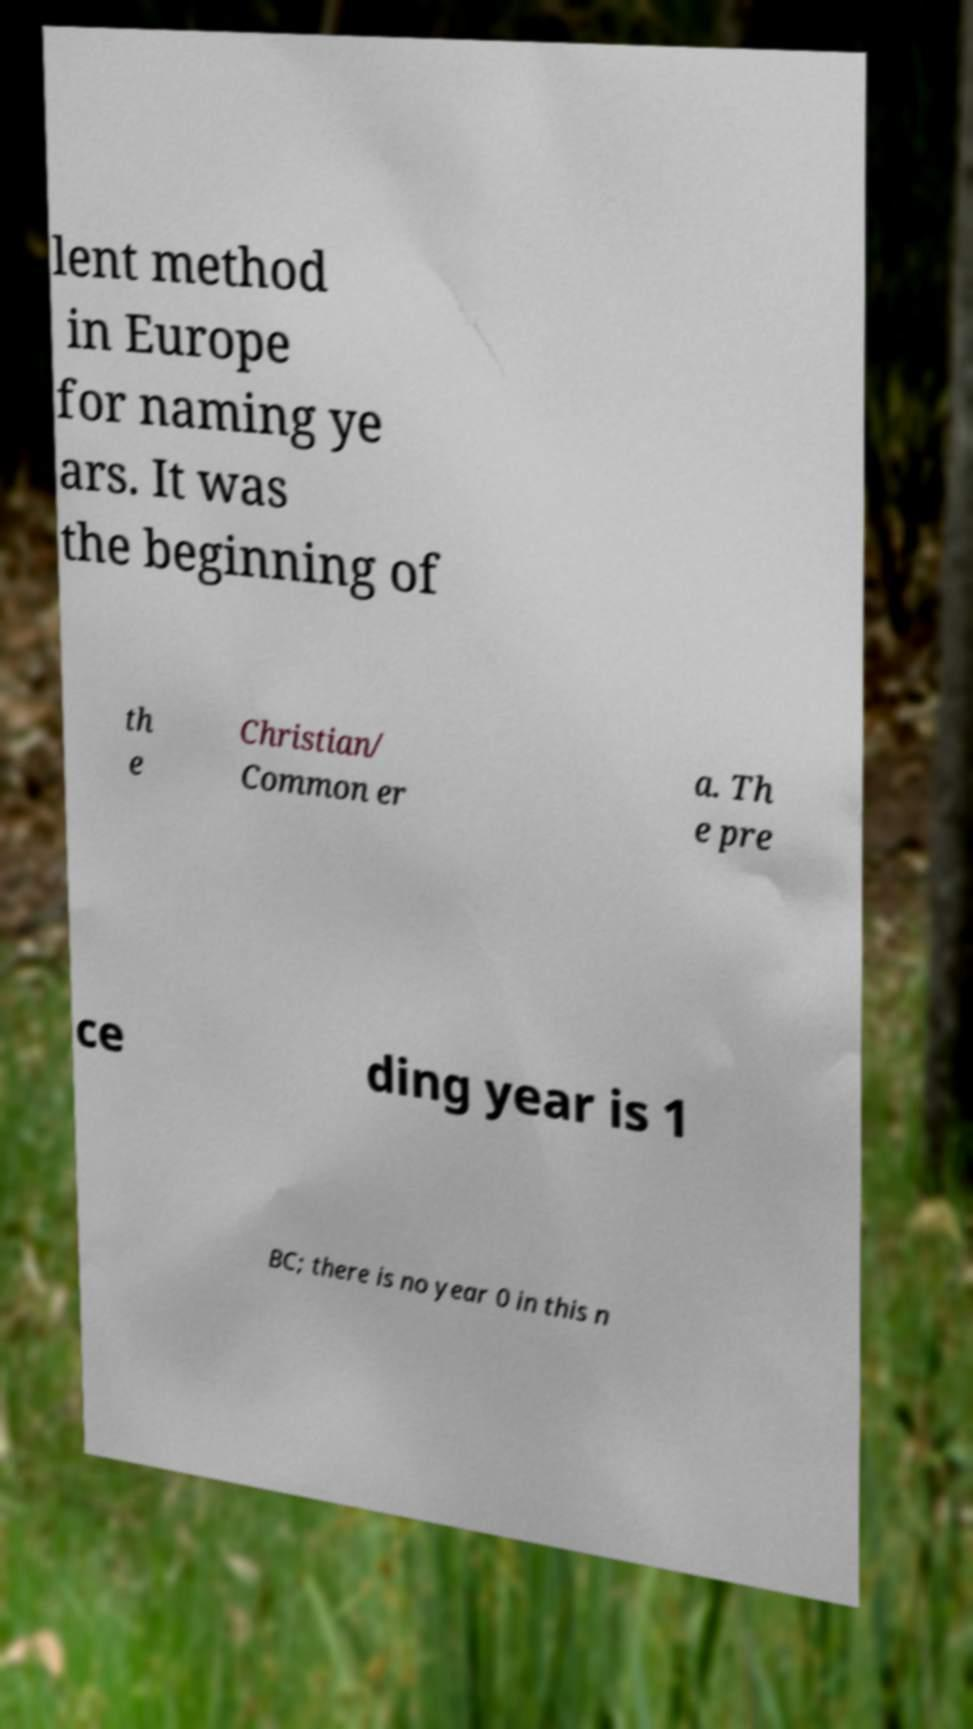Can you read and provide the text displayed in the image?This photo seems to have some interesting text. Can you extract and type it out for me? lent method in Europe for naming ye ars. It was the beginning of th e Christian/ Common er a. Th e pre ce ding year is 1 BC; there is no year 0 in this n 